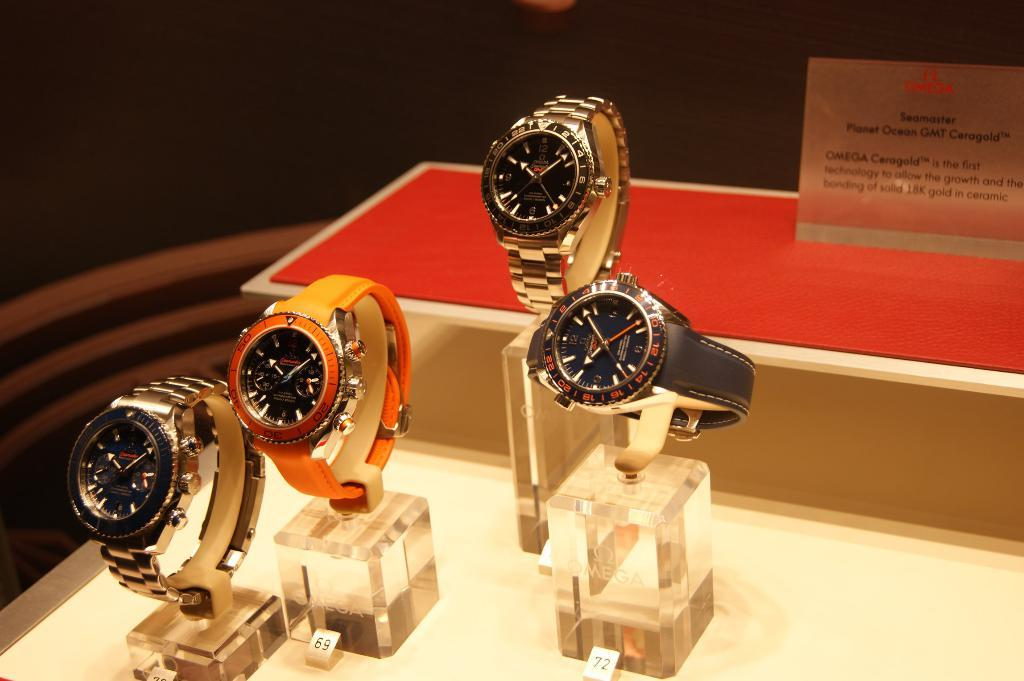What objects are on stands in the image? There are watches on stands in the image. Where are the watches placed? The watches are placed on a table. What else can be seen on the table in the image? There is a sheet with text in the image. What type of umbrella is being used to display the watches in the image? There is no umbrella present in the image; the watches are displayed on stands. What is the writing on the sheet about? The provided facts do not mention the content of the text on the sheet, so it cannot be determined from the image. 